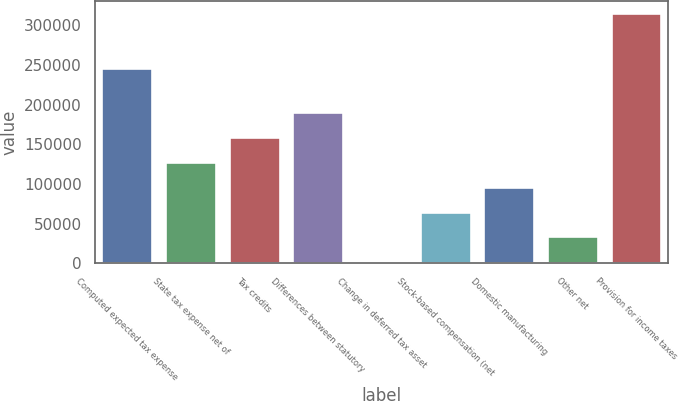Convert chart. <chart><loc_0><loc_0><loc_500><loc_500><bar_chart><fcel>Computed expected tax expense<fcel>State tax expense net of<fcel>Tax credits<fcel>Differences between statutory<fcel>Change in deferred tax asset<fcel>Stock-based compensation (net<fcel>Domestic manufacturing<fcel>Other net<fcel>Provision for income taxes<nl><fcel>245532<fcel>127660<fcel>158886<fcel>190111<fcel>2759<fcel>65209.6<fcel>96434.9<fcel>33984.3<fcel>315012<nl></chart> 